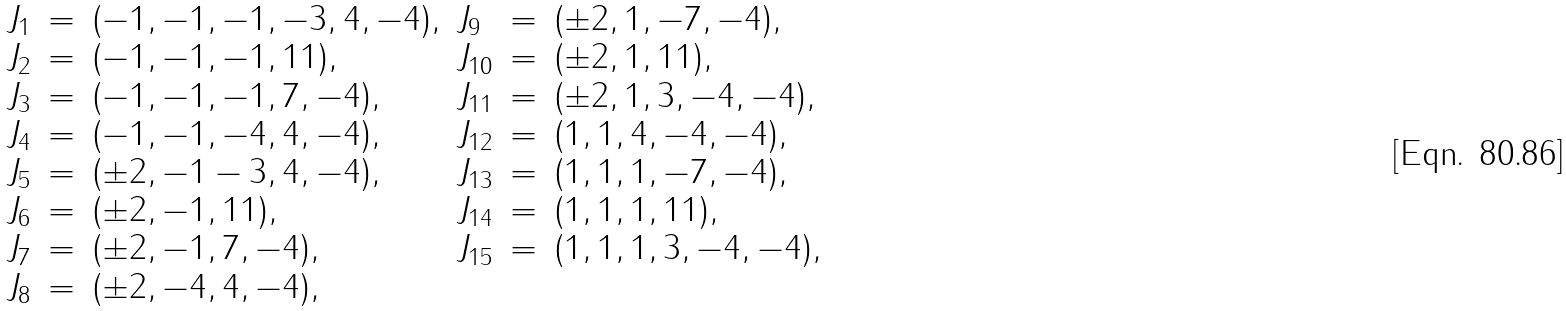Convert formula to latex. <formula><loc_0><loc_0><loc_500><loc_500>\begin{array} { l l l l l l } J _ { 1 } & = & ( - 1 , - 1 , - 1 , - 3 , 4 , - 4 ) , & J _ { 9 } & = & ( \pm 2 , 1 , - 7 , - 4 ) , \\ J _ { 2 } & = & ( - 1 , - 1 , - 1 , 1 1 ) , & J _ { 1 0 } & = & ( \pm 2 , 1 , 1 1 ) , \\ J _ { 3 } & = & ( - 1 , - 1 , - 1 , 7 , - 4 ) , & J _ { 1 1 } & = & ( \pm 2 , 1 , 3 , - 4 , - 4 ) , \\ J _ { 4 } & = & ( - 1 , - 1 , - 4 , 4 , - 4 ) , & J _ { 1 2 } & = & ( 1 , 1 , 4 , - 4 , - 4 ) , \\ J _ { 5 } & = & ( \pm 2 , - 1 - 3 , 4 , - 4 ) , & J _ { 1 3 } & = & ( 1 , 1 , 1 , - 7 , - 4 ) , \\ J _ { 6 } & = & ( \pm 2 , - 1 , 1 1 ) , & J _ { 1 4 } & = & ( 1 , 1 , 1 , 1 1 ) , \\ J _ { 7 } & = & ( \pm 2 , - 1 , 7 , - 4 ) , & J _ { 1 5 } & = & ( 1 , 1 , 1 , 3 , - 4 , - 4 ) , \\ J _ { 8 } & = & ( \pm 2 , - 4 , 4 , - 4 ) , & & & \end{array}</formula> 